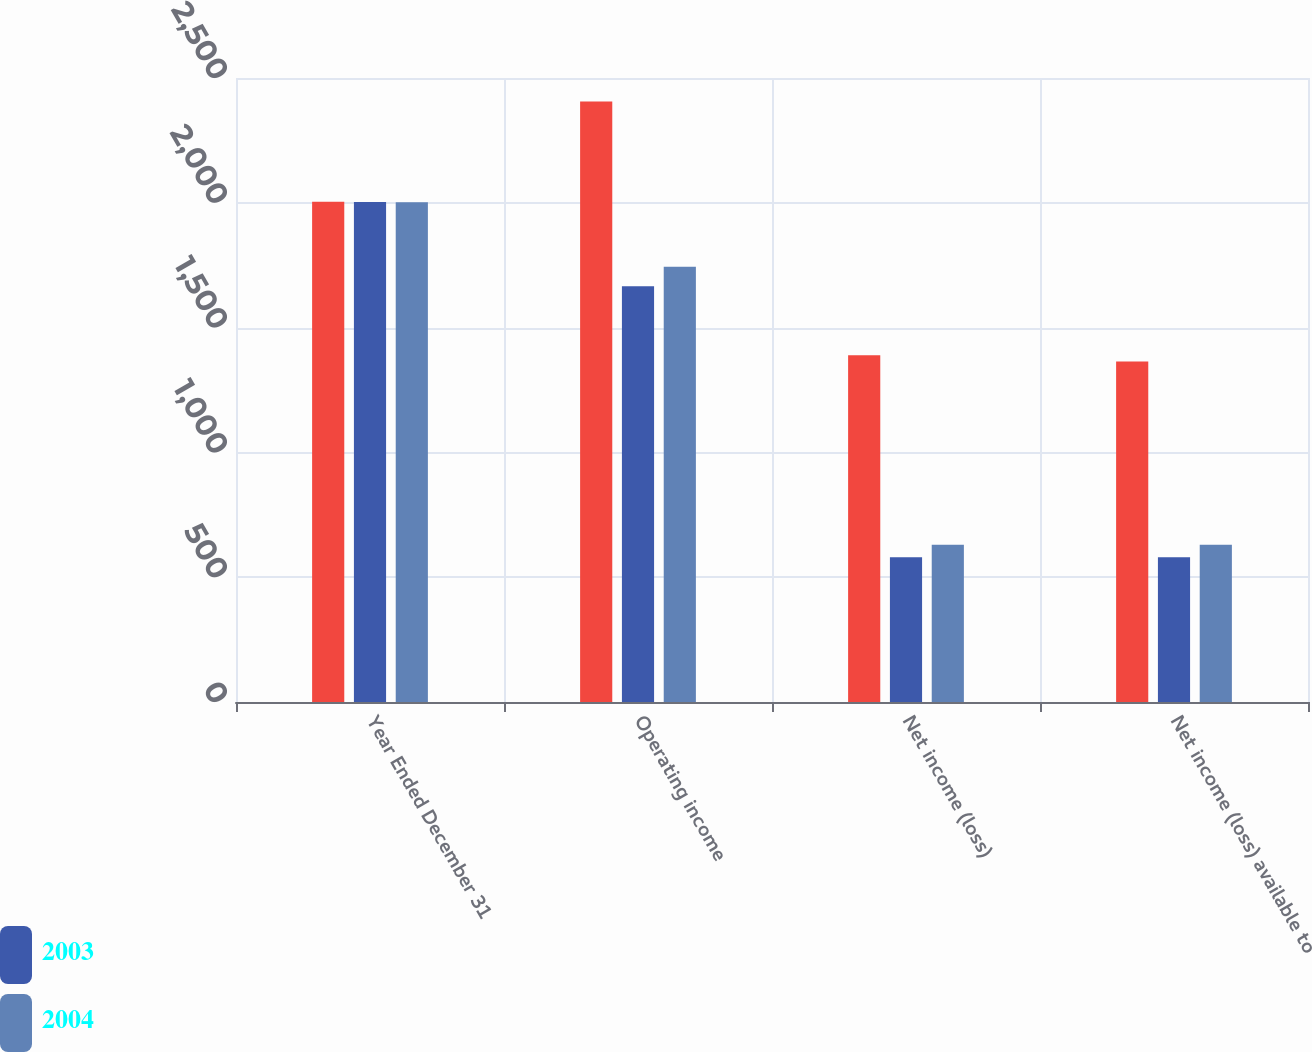Convert chart. <chart><loc_0><loc_0><loc_500><loc_500><stacked_bar_chart><ecel><fcel>Year Ended December 31<fcel>Operating income<fcel>Net income (loss)<fcel>Net income (loss) available to<nl><fcel>nan<fcel>2004<fcel>2406<fcel>1389<fcel>1364<nl><fcel>2003<fcel>2003<fcel>1666<fcel>580<fcel>580<nl><fcel>2004<fcel>2002<fcel>1744<fcel>630<fcel>630<nl></chart> 